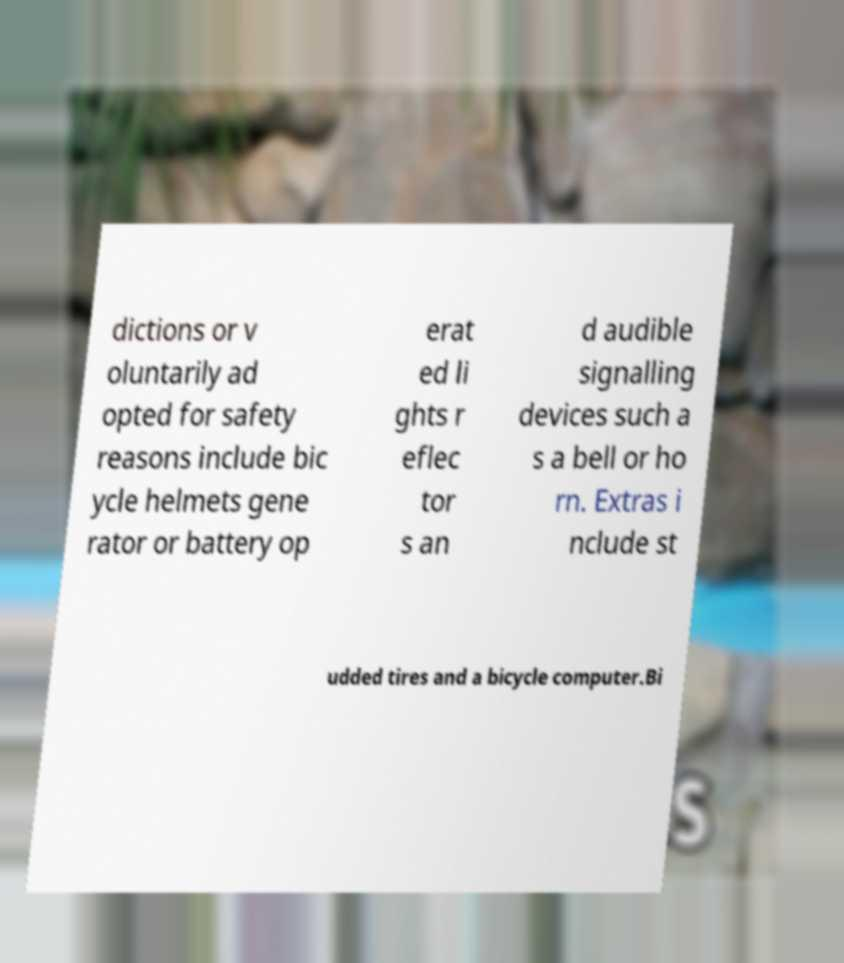There's text embedded in this image that I need extracted. Can you transcribe it verbatim? dictions or v oluntarily ad opted for safety reasons include bic ycle helmets gene rator or battery op erat ed li ghts r eflec tor s an d audible signalling devices such a s a bell or ho rn. Extras i nclude st udded tires and a bicycle computer.Bi 